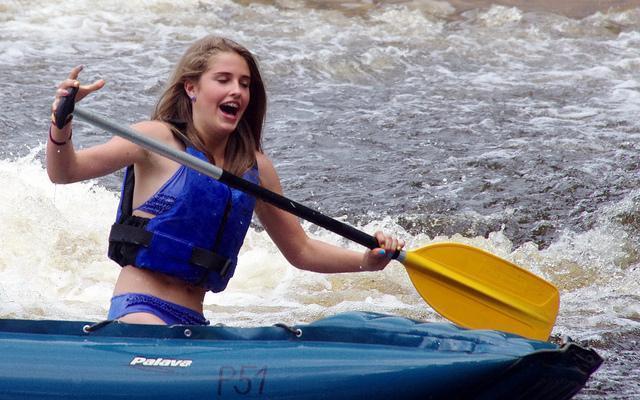Does the image validate the caption "The boat is connected to the person."?
Answer yes or no. Yes. 